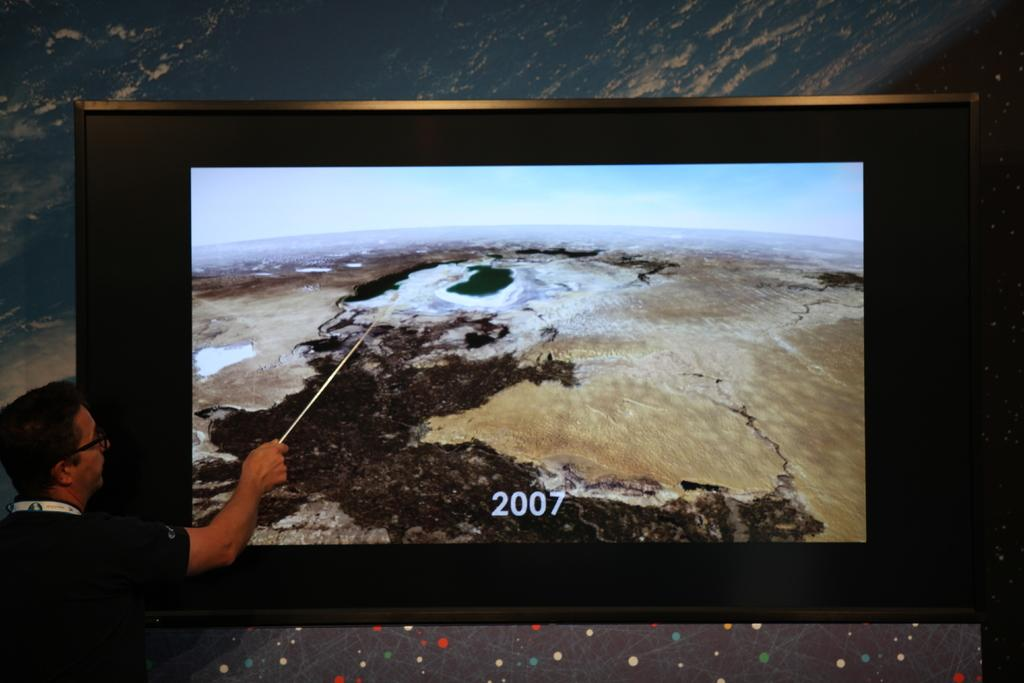<image>
Share a concise interpretation of the image provided. A man points to a spot on the screen with 2007 on it. 